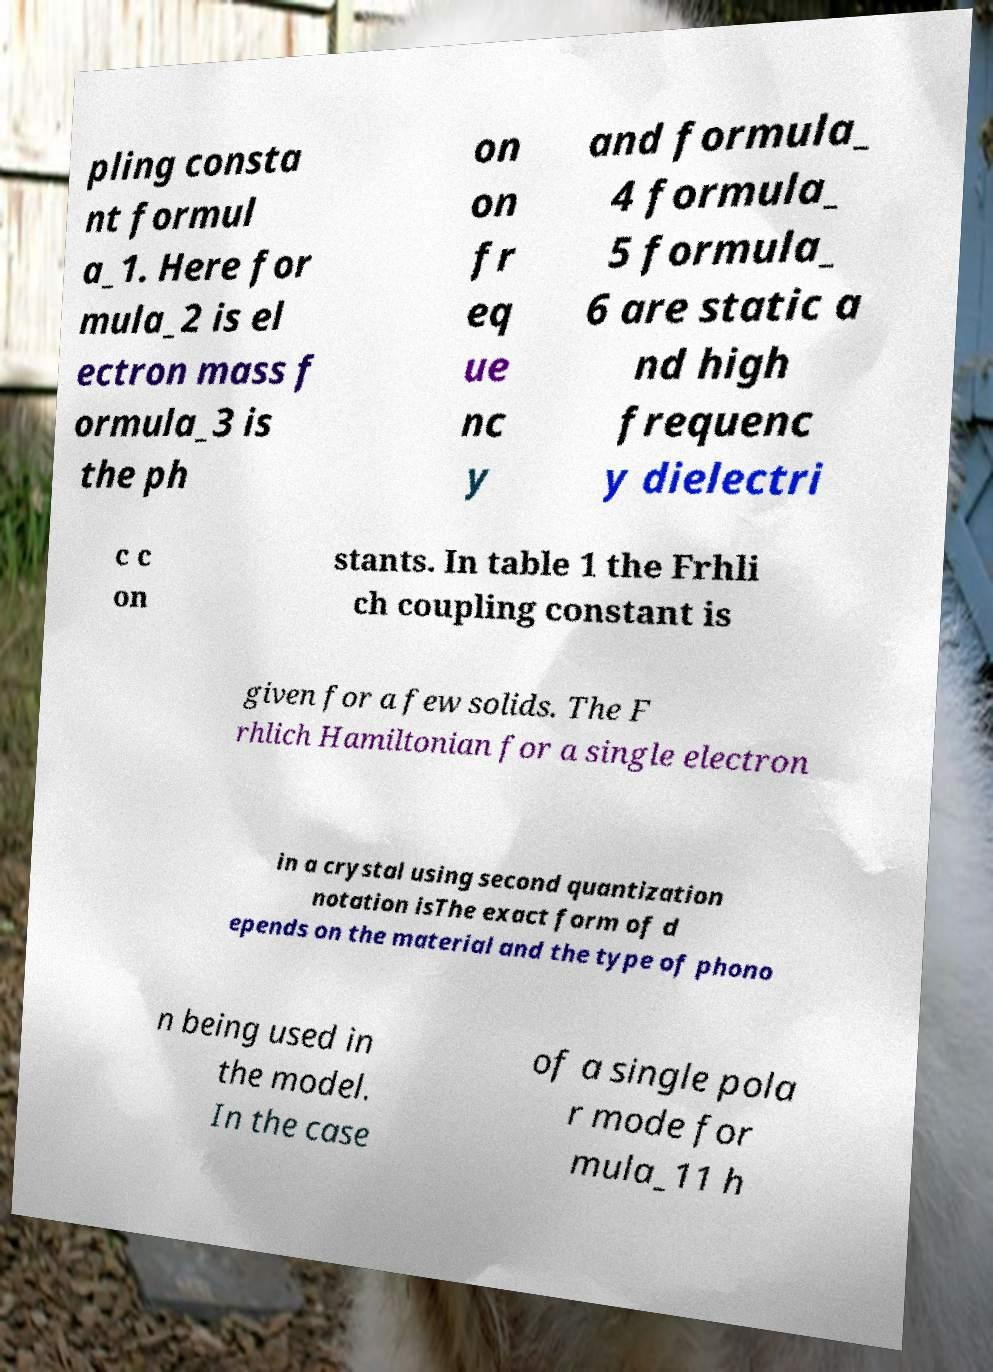Could you assist in decoding the text presented in this image and type it out clearly? pling consta nt formul a_1. Here for mula_2 is el ectron mass f ormula_3 is the ph on on fr eq ue nc y and formula_ 4 formula_ 5 formula_ 6 are static a nd high frequenc y dielectri c c on stants. In table 1 the Frhli ch coupling constant is given for a few solids. The F rhlich Hamiltonian for a single electron in a crystal using second quantization notation isThe exact form of d epends on the material and the type of phono n being used in the model. In the case of a single pola r mode for mula_11 h 